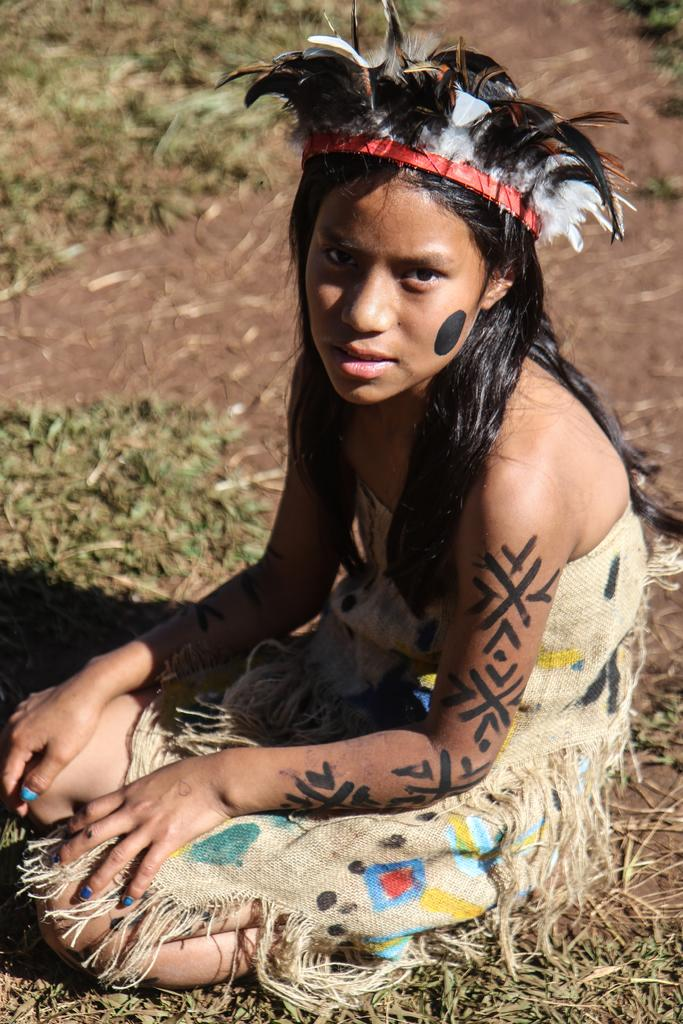What is the person in the image doing? The person is sitting in the image. What is the person wearing? The person is wearing a cream-colored dress. What can be seen in the background of the image? The background of the image includes green grass. What type of cats are present at the meeting in the image? There are no cats or meetings present in the image; it features a person sitting with green grass in the background. 